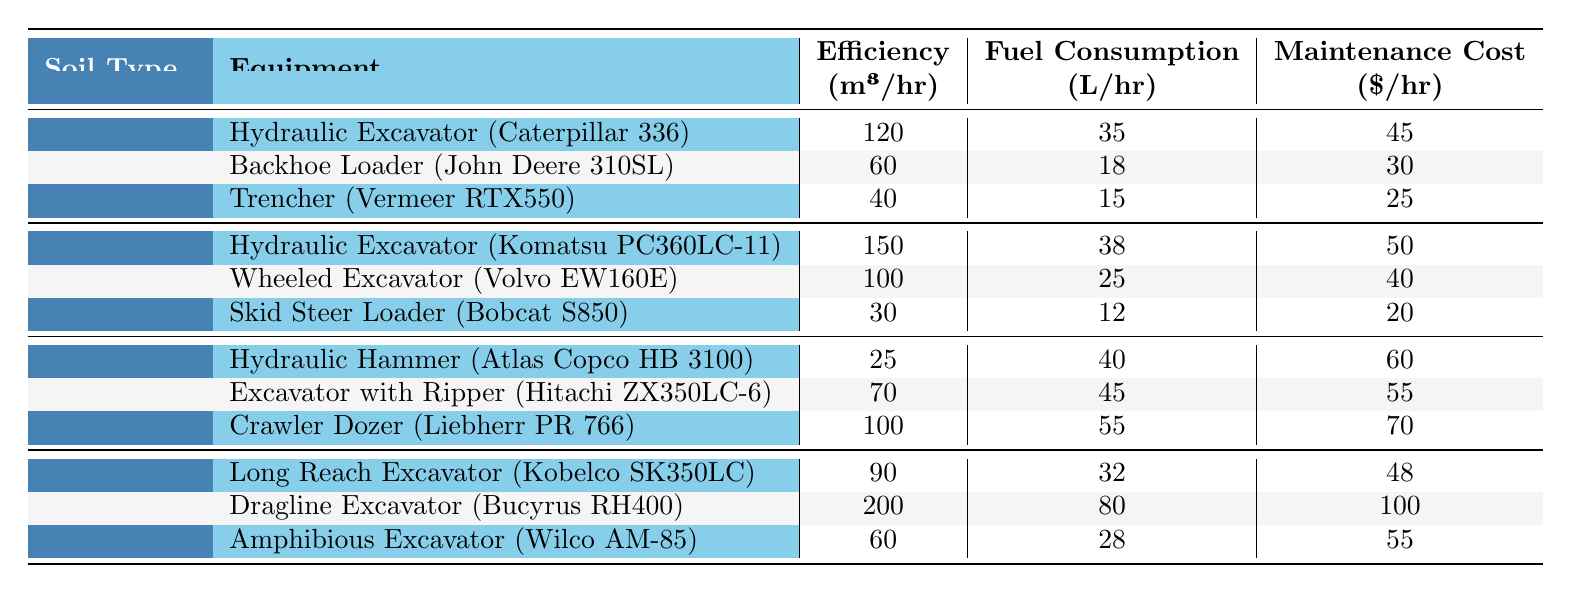What is the highest efficiency equipment for Silty Soil? The table shows that the Dragline Excavator (Bucyrus RH400) has the highest efficiency at 200 m³/hr when considering Silty Soil.
Answer: 200 m³/hr Which equipment has the lowest fuel consumption among all types of equipment? By reviewing the fuel consumption values listed, the Skid Steer Loader (Bobcat S850) has the lowest fuel consumption at 12 L/hr.
Answer: 12 L/hr What is the total maintenance cost of using a Hydraulic Excavator for Clay soil? The maintenance cost for the Hydraulic Excavator (Caterpillar 336) is $45/hr, so for an hour of use on Clay soil, the total maintenance cost will also be $45.
Answer: $45 Which soil type has the highest average equipment efficiency? To find the average, we first sum the efficiencies for each soil type: Clay (120 + 60 + 40 = 220), Sandy Loam (150 + 100 + 30 = 280), Rocky Soil (25 + 70 + 100 = 195), Silty Soil (90 + 200 + 60 = 350). Then, we divide each by 3: Clay (220/3 ≈ 73.33), Sandy Loam (280/3 ≈ 93.33), Rocky Soil (195/3 = 65), Silty Soil (350/3 ≈ 116.67). The highest average efficiency is for Silty Soil at approximately 116.67 m³/hr.
Answer: Silty Soil Is the maintenance cost of the Backhoe Loader less than the Hydraulic Hammer? The maintenance cost for the Backhoe Loader (John Deere 310SL) is $30/hr and for the Hydraulic Hammer (Atlas Copco HB 3100) it is $60/hr. Since $30 is less than $60, the statement is true.
Answer: Yes What is the difference in fuel consumption between the most and least efficient equipment for Sandy Loam? The most efficient equipment is the Hydraulic Excavator (Komatsu PC360LC-11) at 38 L/hr, and the least efficient is the Skid Steer Loader (Bobcat S850) at 12 L/hr. The difference is 38 - 12 = 26 L/hr.
Answer: 26 L/hr Which type of equipment has the highest maintenance cost for Rocky Soil? Looking at the maintenance costs for Rocky Soil: Hydraulic Hammer is $60/hr, Excavator with Ripper is $55/hr, and Crawler Dozer is $70/hr. The Crawler Dozer has the highest maintenance cost at $70/hr.
Answer: $70/hr How much more efficient is the Dragline Excavator compared to the Long Reach Excavator? The Dragline Excavator's efficiency is 200 m³/hr and the Long Reach Excavator's efficiency is 90 m³/hr. The difference is 200 - 90 = 110 m³/hr, indicating that the Dragline Excavator is more efficient by 110 m³/hr.
Answer: 110 m³/hr For what type of soil is the Backhoe Loader most efficient according to its performance? The Backhoe Loader (John Deere 310SL) has an efficiency of 60 m³/hr in Clay Soil, which is the only soil type listed for this equipment. Therefore, it is most efficient for Clay soil.
Answer: Clay Soil Which equipment combines the best efficiency and lowest maintenance cost for Silty Soil? Comparing the equipment for Silty Soil: Long Reach Excavator (90 m³/hr, $48/hr), Dragline Excavator (200 m³/hr, $100/hr), Amphibious Excavator (60 m³/hr, $55/hr). The Long Reach Excavator has a good compromise of efficiency and maintenance cost: efficiency $90 m³/hr and maintenance $48/hr, giving it the best ratio.
Answer: Long Reach Excavator 